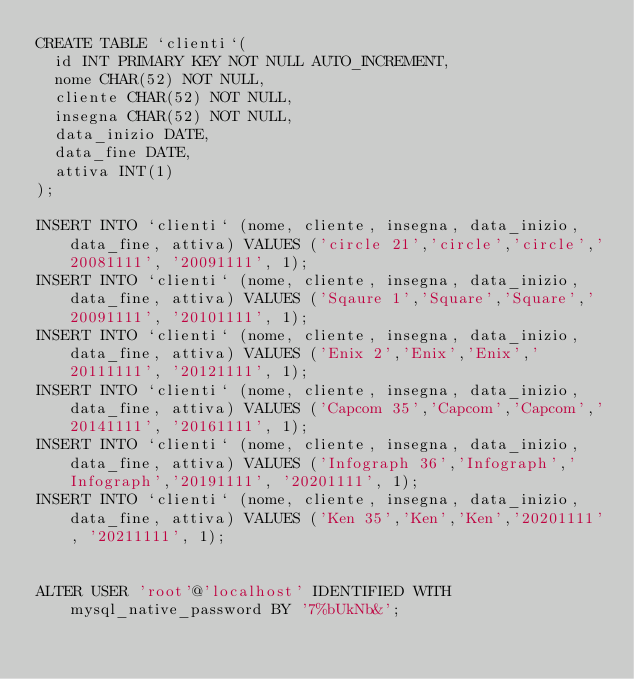<code> <loc_0><loc_0><loc_500><loc_500><_SQL_>CREATE TABLE `clienti`(
  id INT PRIMARY KEY NOT NULL AUTO_INCREMENT,
  nome CHAR(52) NOT NULL,
  cliente CHAR(52) NOT NULL,
  insegna CHAR(52) NOT NULL,
  data_inizio DATE,
  data_fine DATE,
  attiva INT(1)
); 

INSERT INTO `clienti` (nome, cliente, insegna, data_inizio, data_fine, attiva) VALUES ('circle 21','circle','circle','20081111', '20091111', 1);
INSERT INTO `clienti` (nome, cliente, insegna, data_inizio, data_fine, attiva) VALUES ('Sqaure 1','Square','Square','20091111', '20101111', 1);
INSERT INTO `clienti` (nome, cliente, insegna, data_inizio, data_fine, attiva) VALUES ('Enix 2','Enix','Enix','20111111', '20121111', 1);
INSERT INTO `clienti` (nome, cliente, insegna, data_inizio, data_fine, attiva) VALUES ('Capcom 35','Capcom','Capcom','20141111', '20161111', 1);
INSERT INTO `clienti` (nome, cliente, insegna, data_inizio, data_fine, attiva) VALUES ('Infograph 36','Infograph','Infograph','20191111', '20201111', 1);
INSERT INTO `clienti` (nome, cliente, insegna, data_inizio, data_fine, attiva) VALUES ('Ken 35','Ken','Ken','20201111', '20211111', 1);


ALTER USER 'root'@'localhost' IDENTIFIED WITH mysql_native_password BY '7%bUkNb&';

</code> 